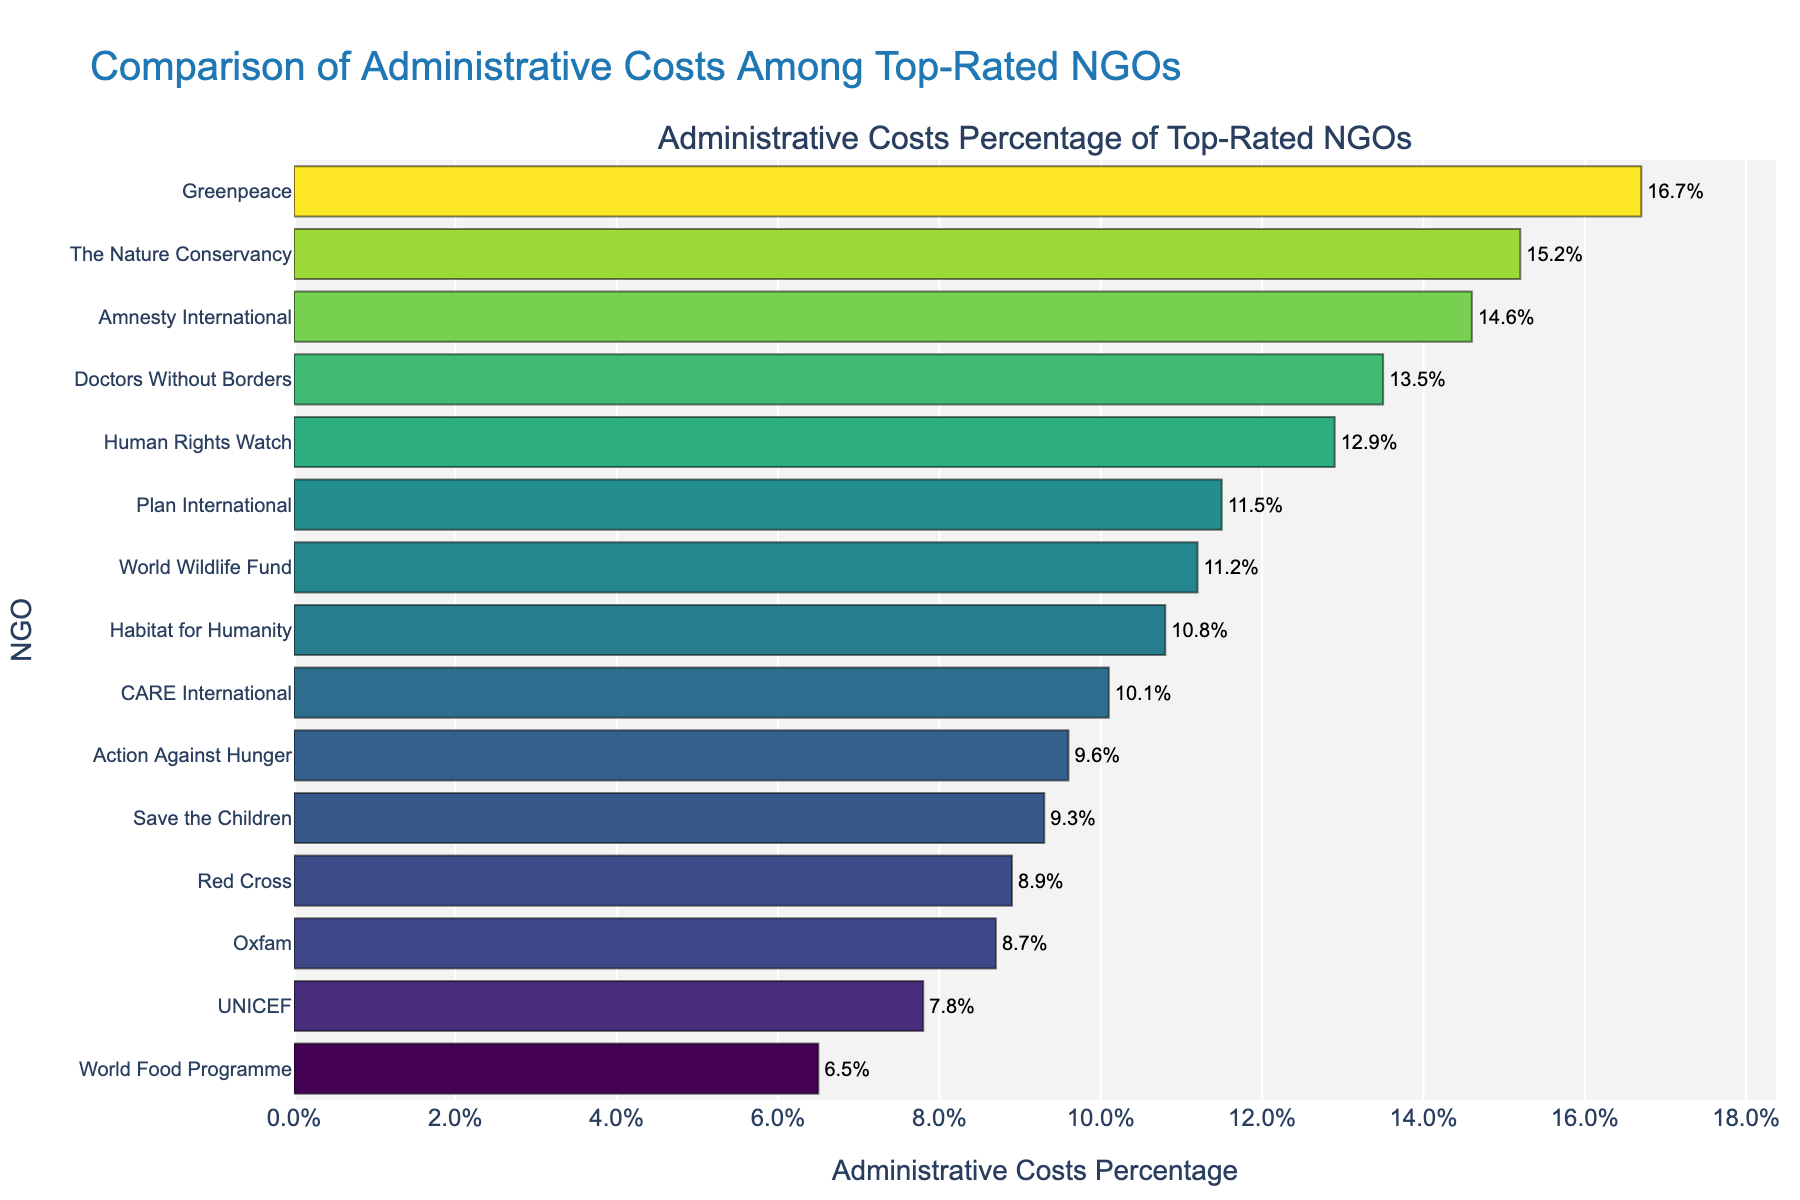Which NGO has the highest administrative costs percentage? By looking at the chart, the NGO with the highest bar represents the highest administrative costs percentage.
Answer: Greenpeace Which NGO has the lowest administrative costs percentage? The NGO with the shortest bar represents the lowest administrative costs percentage.
Answer: World Food Programme Among the NGOs in the Environmental Conservation sector, which one has the higher administrative costs percentage? Compare the bars of the World Wildlife Fund and The Nature Conservancy. The Nature Conservancy has a longer bar.
Answer: The Nature Conservancy What is the difference in administrative costs percentage between Human Rights Watch and Amnesty International? Identify the bars for Human Rights Watch and Amnesty International, then calculate the difference between their percentages (14.6% - 12.9%).
Answer: 1.7% What is the average administrative costs percentage of the NGOs in the Child Welfare, Children's Rights, and Child Development sectors? Calculate the average of percentages for Save the Children (9.3%), UNICEF (7.8%), and Plan International (11.5%). (9.3 + 7.8 + 11.5) / 3.
Answer: 9.53% Which sector has the greatest range in administrative costs percentages among its NGOs? Compare the ranges (difference between highest and lowest percentage) within each sector. Environmental Conservation has the greatest range (15.2% - 11.2%).
Answer: Environmental Conservation What's the combined administrative costs percentage of CARE International, Action Against Hunger, and Habitat for Humanity? Add the percentages for CARE International (10.1%), Action Against Hunger (9.6%), and Habitat for Humanity (10.8%). (10.1 + 9.6 + 10.8)
Answer: 30.5% Is there an NGO whose administrative costs percentage is exactly the median value among all listed NGOs? List all percentages and find the median value. Look for an NGO with this exact percentage. The median is the average of the 7th and 8th values in the list sorted by percentage. For our set, it's the average of 10.1% and 10.8%, which is 10.45%. No NGO has this exact value.
Answer: No Between Disaster Relief and Humanitarian Aid sectors, which has a lower administrative costs percentage on average? Average the percentages for Disaster Relief (Red Cross, 8.9%) and Humanitarian Aid (CARE International, 10.1%), then compare the averages.
Answer: Disaster Relief (8.9%) 